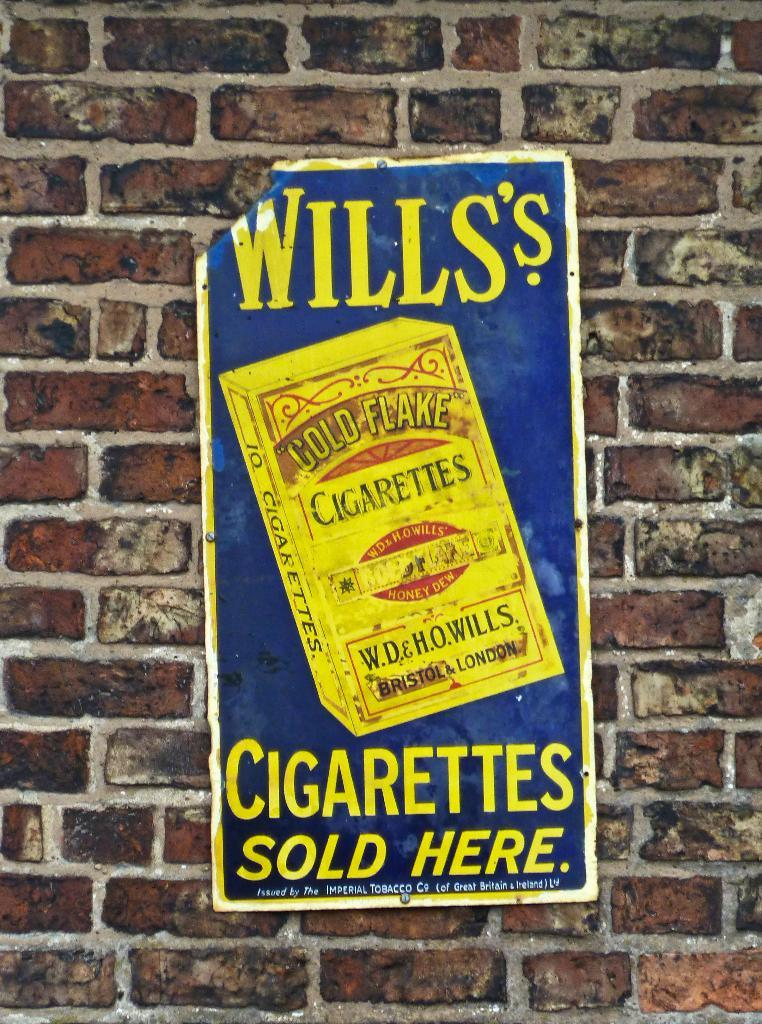<image>
Offer a succinct explanation of the picture presented. the word cigarettes is on the blue poster 